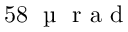Convert formula to latex. <formula><loc_0><loc_0><loc_500><loc_500>5 8 \, \text  mu   r a d</formula> 